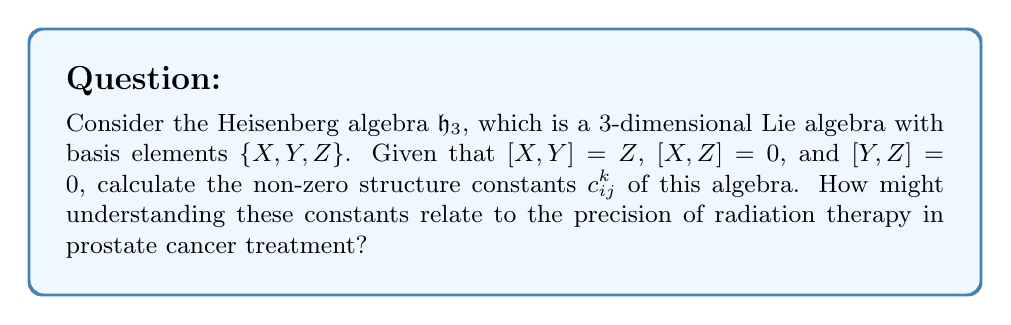Give your solution to this math problem. Let's approach this step-by-step:

1) The structure constants $c_{ij}^k$ are defined by the relation:

   $$[e_i, e_j] = \sum_k c_{ij}^k e_k$$

   where $e_i$, $e_j$, and $e_k$ are basis elements of the Lie algebra.

2) In our case, we have:
   $e_1 = X$, $e_2 = Y$, $e_3 = Z$

3) From the given relations:
   $[X,Y] = Z$ implies $[e_1, e_2] = e_3$
   $[X,Z] = 0$ implies $[e_1, e_3] = 0$
   $[Y,Z] = 0$ implies $[e_2, e_3] = 0$

4) Comparing with the general form:
   $[e_1, e_2] = c_{12}^1 e_1 + c_{12}^2 e_2 + c_{12}^3 e_3 = e_3$

   This means: $c_{12}^1 = 0$, $c_{12}^2 = 0$, $c_{12}^3 = 1$

5) All other structure constants are zero due to the other relations.

6) Note that $c_{21}^3 = -c_{12}^3 = -1$ due to the antisymmetry of the Lie bracket.

The connection to prostate cancer treatment lies in the precision of radiation therapy. The Heisenberg algebra is fundamental in quantum mechanics, which underlies the physics of radiation. Understanding the structure of this algebra can lead to more precise models of radiation interaction with tissue, potentially allowing for more targeted and effective treatments with reduced side effects.
Answer: The non-zero structure constants of the Heisenberg algebra $\mathfrak{h}_3$ are:

$$c_{12}^3 = 1$$
$$c_{21}^3 = -1$$

All other $c_{ij}^k = 0$. 